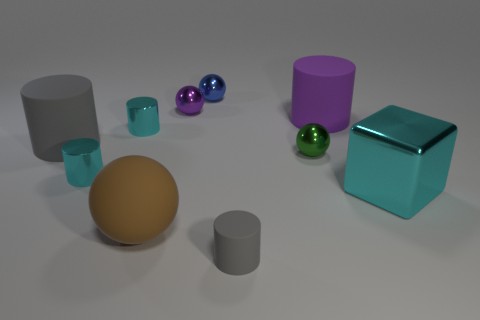There is a matte thing that is behind the gray cylinder behind the cyan metal object that is to the right of the small gray cylinder; what size is it?
Ensure brevity in your answer.  Large. Do the small cylinder that is in front of the large metallic block and the big cylinder that is left of the blue metal sphere have the same color?
Offer a terse response. Yes. How many yellow objects are either tiny shiny spheres or tiny objects?
Provide a short and direct response. 0. What number of brown balls have the same size as the blue object?
Offer a terse response. 0. Are the cyan object to the right of the large sphere and the brown ball made of the same material?
Make the answer very short. No. Is there a purple rubber object that is in front of the cyan thing that is to the right of the small rubber object?
Your response must be concise. No. What is the material of the small green thing that is the same shape as the tiny purple metallic object?
Keep it short and to the point. Metal. Is the number of tiny balls that are in front of the blue metallic ball greater than the number of large cyan metal things right of the brown matte object?
Ensure brevity in your answer.  Yes. There is a purple object that is made of the same material as the big ball; what shape is it?
Offer a terse response. Cylinder. Are there more large cyan metal objects behind the large brown thing than big gray metallic cylinders?
Keep it short and to the point. Yes. 